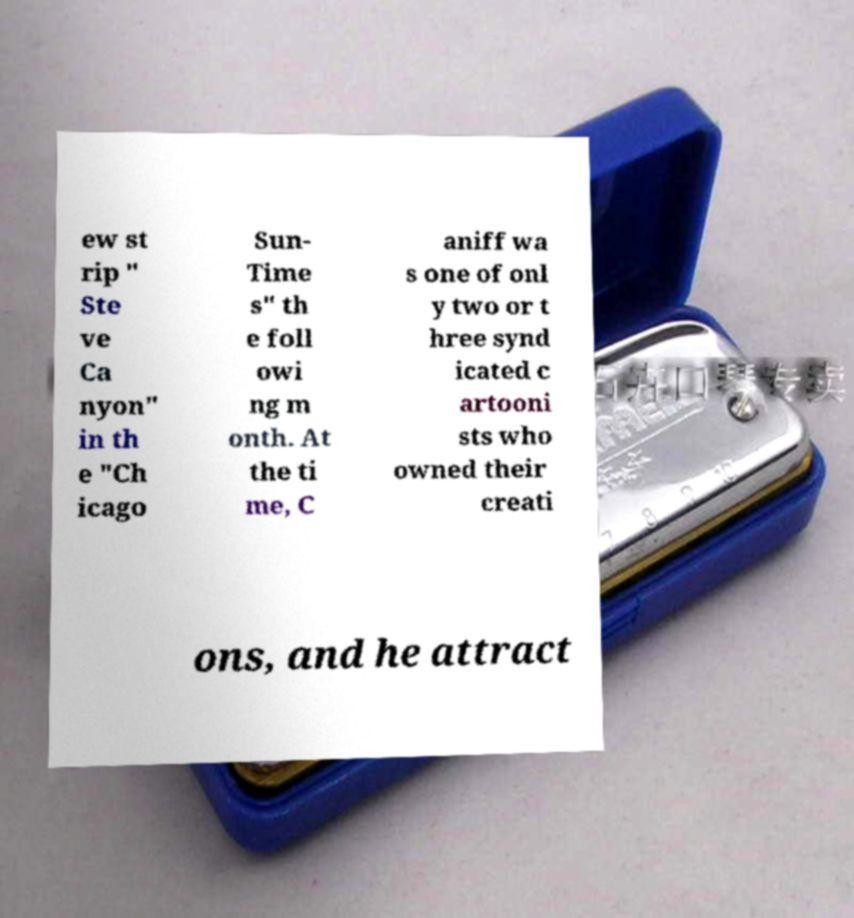There's text embedded in this image that I need extracted. Can you transcribe it verbatim? ew st rip " Ste ve Ca nyon" in th e "Ch icago Sun- Time s" th e foll owi ng m onth. At the ti me, C aniff wa s one of onl y two or t hree synd icated c artooni sts who owned their creati ons, and he attract 